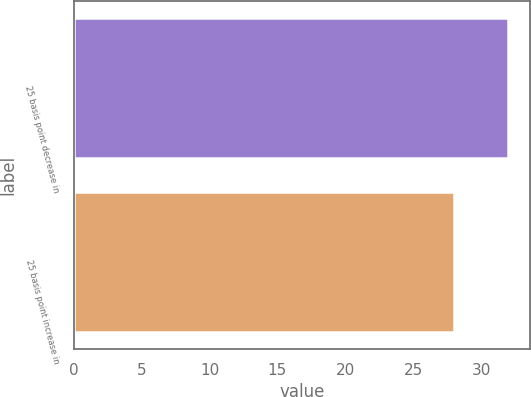Convert chart to OTSL. <chart><loc_0><loc_0><loc_500><loc_500><bar_chart><fcel>25 basis point decrease in<fcel>25 basis point increase in<nl><fcel>32<fcel>28<nl></chart> 